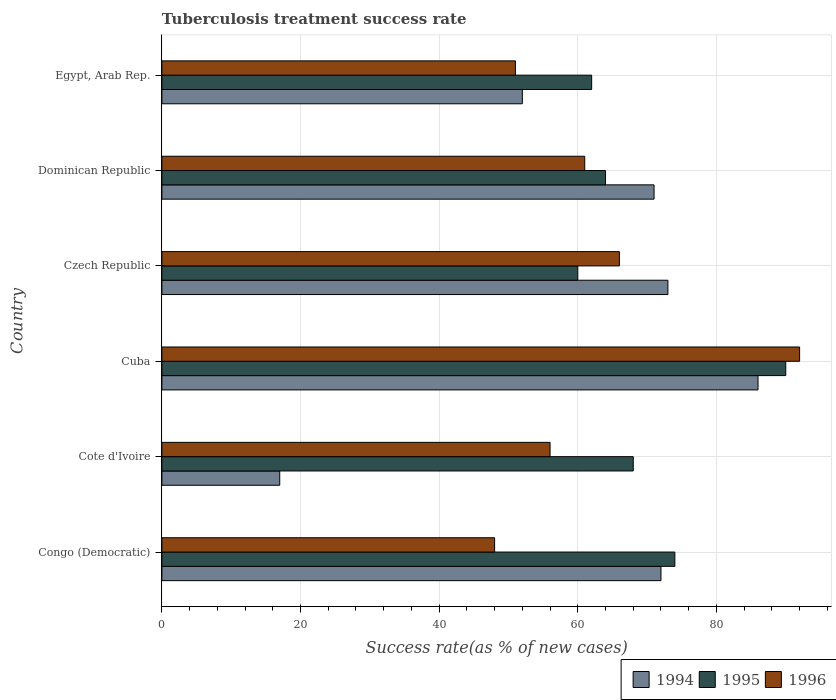Are the number of bars on each tick of the Y-axis equal?
Your response must be concise. Yes. How many bars are there on the 3rd tick from the bottom?
Keep it short and to the point. 3. What is the label of the 3rd group of bars from the top?
Offer a very short reply. Czech Republic. Across all countries, what is the maximum tuberculosis treatment success rate in 1994?
Give a very brief answer. 86. Across all countries, what is the minimum tuberculosis treatment success rate in 1995?
Give a very brief answer. 60. In which country was the tuberculosis treatment success rate in 1994 maximum?
Offer a very short reply. Cuba. In which country was the tuberculosis treatment success rate in 1995 minimum?
Your answer should be very brief. Czech Republic. What is the total tuberculosis treatment success rate in 1995 in the graph?
Your answer should be compact. 418. What is the difference between the tuberculosis treatment success rate in 1995 in Cote d'Ivoire and that in Egypt, Arab Rep.?
Make the answer very short. 6. What is the difference between the tuberculosis treatment success rate in 1996 in Czech Republic and the tuberculosis treatment success rate in 1994 in Dominican Republic?
Your answer should be compact. -5. What is the average tuberculosis treatment success rate in 1996 per country?
Your answer should be very brief. 62.33. What is the ratio of the tuberculosis treatment success rate in 1996 in Cote d'Ivoire to that in Egypt, Arab Rep.?
Your answer should be very brief. 1.1. What is the difference between the highest and the lowest tuberculosis treatment success rate in 1996?
Ensure brevity in your answer.  44. In how many countries, is the tuberculosis treatment success rate in 1994 greater than the average tuberculosis treatment success rate in 1994 taken over all countries?
Offer a very short reply. 4. Is the sum of the tuberculosis treatment success rate in 1994 in Cuba and Czech Republic greater than the maximum tuberculosis treatment success rate in 1995 across all countries?
Keep it short and to the point. Yes. What does the 3rd bar from the bottom in Dominican Republic represents?
Your answer should be compact. 1996. Is it the case that in every country, the sum of the tuberculosis treatment success rate in 1994 and tuberculosis treatment success rate in 1995 is greater than the tuberculosis treatment success rate in 1996?
Your answer should be compact. Yes. How many bars are there?
Your answer should be compact. 18. Are all the bars in the graph horizontal?
Provide a short and direct response. Yes. How many countries are there in the graph?
Your answer should be very brief. 6. What is the difference between two consecutive major ticks on the X-axis?
Offer a terse response. 20. Are the values on the major ticks of X-axis written in scientific E-notation?
Offer a very short reply. No. Does the graph contain grids?
Make the answer very short. Yes. Where does the legend appear in the graph?
Provide a succinct answer. Bottom right. How many legend labels are there?
Keep it short and to the point. 3. What is the title of the graph?
Offer a very short reply. Tuberculosis treatment success rate. Does "1980" appear as one of the legend labels in the graph?
Your answer should be compact. No. What is the label or title of the X-axis?
Make the answer very short. Success rate(as % of new cases). What is the Success rate(as % of new cases) in 1994 in Congo (Democratic)?
Ensure brevity in your answer.  72. What is the Success rate(as % of new cases) in 1995 in Congo (Democratic)?
Make the answer very short. 74. What is the Success rate(as % of new cases) in 1994 in Cote d'Ivoire?
Provide a succinct answer. 17. What is the Success rate(as % of new cases) of 1996 in Cote d'Ivoire?
Your answer should be compact. 56. What is the Success rate(as % of new cases) of 1996 in Cuba?
Give a very brief answer. 92. What is the Success rate(as % of new cases) in 1995 in Egypt, Arab Rep.?
Your answer should be compact. 62. Across all countries, what is the maximum Success rate(as % of new cases) of 1994?
Give a very brief answer. 86. Across all countries, what is the maximum Success rate(as % of new cases) of 1995?
Provide a succinct answer. 90. Across all countries, what is the maximum Success rate(as % of new cases) in 1996?
Ensure brevity in your answer.  92. Across all countries, what is the minimum Success rate(as % of new cases) of 1994?
Give a very brief answer. 17. Across all countries, what is the minimum Success rate(as % of new cases) of 1995?
Your answer should be compact. 60. Across all countries, what is the minimum Success rate(as % of new cases) of 1996?
Give a very brief answer. 48. What is the total Success rate(as % of new cases) in 1994 in the graph?
Make the answer very short. 371. What is the total Success rate(as % of new cases) in 1995 in the graph?
Ensure brevity in your answer.  418. What is the total Success rate(as % of new cases) of 1996 in the graph?
Provide a succinct answer. 374. What is the difference between the Success rate(as % of new cases) of 1996 in Congo (Democratic) and that in Cote d'Ivoire?
Give a very brief answer. -8. What is the difference between the Success rate(as % of new cases) of 1995 in Congo (Democratic) and that in Cuba?
Your response must be concise. -16. What is the difference between the Success rate(as % of new cases) of 1996 in Congo (Democratic) and that in Cuba?
Your response must be concise. -44. What is the difference between the Success rate(as % of new cases) of 1996 in Congo (Democratic) and that in Czech Republic?
Your answer should be very brief. -18. What is the difference between the Success rate(as % of new cases) of 1995 in Congo (Democratic) and that in Dominican Republic?
Your response must be concise. 10. What is the difference between the Success rate(as % of new cases) of 1994 in Congo (Democratic) and that in Egypt, Arab Rep.?
Your response must be concise. 20. What is the difference between the Success rate(as % of new cases) in 1996 in Congo (Democratic) and that in Egypt, Arab Rep.?
Ensure brevity in your answer.  -3. What is the difference between the Success rate(as % of new cases) in 1994 in Cote d'Ivoire and that in Cuba?
Your answer should be very brief. -69. What is the difference between the Success rate(as % of new cases) of 1995 in Cote d'Ivoire and that in Cuba?
Give a very brief answer. -22. What is the difference between the Success rate(as % of new cases) in 1996 in Cote d'Ivoire and that in Cuba?
Provide a short and direct response. -36. What is the difference between the Success rate(as % of new cases) in 1994 in Cote d'Ivoire and that in Czech Republic?
Provide a succinct answer. -56. What is the difference between the Success rate(as % of new cases) in 1994 in Cote d'Ivoire and that in Dominican Republic?
Your answer should be compact. -54. What is the difference between the Success rate(as % of new cases) of 1995 in Cote d'Ivoire and that in Dominican Republic?
Ensure brevity in your answer.  4. What is the difference between the Success rate(as % of new cases) of 1996 in Cote d'Ivoire and that in Dominican Republic?
Your answer should be very brief. -5. What is the difference between the Success rate(as % of new cases) of 1994 in Cote d'Ivoire and that in Egypt, Arab Rep.?
Provide a short and direct response. -35. What is the difference between the Success rate(as % of new cases) in 1996 in Cote d'Ivoire and that in Egypt, Arab Rep.?
Keep it short and to the point. 5. What is the difference between the Success rate(as % of new cases) of 1994 in Cuba and that in Czech Republic?
Provide a short and direct response. 13. What is the difference between the Success rate(as % of new cases) of 1996 in Cuba and that in Czech Republic?
Offer a terse response. 26. What is the difference between the Success rate(as % of new cases) of 1996 in Cuba and that in Dominican Republic?
Ensure brevity in your answer.  31. What is the difference between the Success rate(as % of new cases) of 1994 in Cuba and that in Egypt, Arab Rep.?
Your answer should be compact. 34. What is the difference between the Success rate(as % of new cases) of 1996 in Cuba and that in Egypt, Arab Rep.?
Give a very brief answer. 41. What is the difference between the Success rate(as % of new cases) of 1994 in Czech Republic and that in Dominican Republic?
Make the answer very short. 2. What is the difference between the Success rate(as % of new cases) of 1995 in Czech Republic and that in Dominican Republic?
Provide a succinct answer. -4. What is the difference between the Success rate(as % of new cases) in 1996 in Czech Republic and that in Egypt, Arab Rep.?
Your answer should be compact. 15. What is the difference between the Success rate(as % of new cases) in 1994 in Dominican Republic and that in Egypt, Arab Rep.?
Make the answer very short. 19. What is the difference between the Success rate(as % of new cases) of 1995 in Dominican Republic and that in Egypt, Arab Rep.?
Offer a terse response. 2. What is the difference between the Success rate(as % of new cases) of 1996 in Dominican Republic and that in Egypt, Arab Rep.?
Provide a succinct answer. 10. What is the difference between the Success rate(as % of new cases) of 1995 in Congo (Democratic) and the Success rate(as % of new cases) of 1996 in Cote d'Ivoire?
Offer a very short reply. 18. What is the difference between the Success rate(as % of new cases) of 1994 in Congo (Democratic) and the Success rate(as % of new cases) of 1995 in Cuba?
Keep it short and to the point. -18. What is the difference between the Success rate(as % of new cases) of 1995 in Congo (Democratic) and the Success rate(as % of new cases) of 1996 in Cuba?
Your response must be concise. -18. What is the difference between the Success rate(as % of new cases) in 1994 in Congo (Democratic) and the Success rate(as % of new cases) in 1995 in Czech Republic?
Offer a very short reply. 12. What is the difference between the Success rate(as % of new cases) of 1994 in Congo (Democratic) and the Success rate(as % of new cases) of 1996 in Czech Republic?
Give a very brief answer. 6. What is the difference between the Success rate(as % of new cases) in 1995 in Congo (Democratic) and the Success rate(as % of new cases) in 1996 in Egypt, Arab Rep.?
Ensure brevity in your answer.  23. What is the difference between the Success rate(as % of new cases) of 1994 in Cote d'Ivoire and the Success rate(as % of new cases) of 1995 in Cuba?
Your answer should be very brief. -73. What is the difference between the Success rate(as % of new cases) in 1994 in Cote d'Ivoire and the Success rate(as % of new cases) in 1996 in Cuba?
Ensure brevity in your answer.  -75. What is the difference between the Success rate(as % of new cases) of 1995 in Cote d'Ivoire and the Success rate(as % of new cases) of 1996 in Cuba?
Keep it short and to the point. -24. What is the difference between the Success rate(as % of new cases) of 1994 in Cote d'Ivoire and the Success rate(as % of new cases) of 1995 in Czech Republic?
Ensure brevity in your answer.  -43. What is the difference between the Success rate(as % of new cases) in 1994 in Cote d'Ivoire and the Success rate(as % of new cases) in 1996 in Czech Republic?
Provide a short and direct response. -49. What is the difference between the Success rate(as % of new cases) of 1994 in Cote d'Ivoire and the Success rate(as % of new cases) of 1995 in Dominican Republic?
Offer a very short reply. -47. What is the difference between the Success rate(as % of new cases) of 1994 in Cote d'Ivoire and the Success rate(as % of new cases) of 1996 in Dominican Republic?
Your response must be concise. -44. What is the difference between the Success rate(as % of new cases) in 1994 in Cote d'Ivoire and the Success rate(as % of new cases) in 1995 in Egypt, Arab Rep.?
Your response must be concise. -45. What is the difference between the Success rate(as % of new cases) in 1994 in Cote d'Ivoire and the Success rate(as % of new cases) in 1996 in Egypt, Arab Rep.?
Your answer should be compact. -34. What is the difference between the Success rate(as % of new cases) in 1995 in Cote d'Ivoire and the Success rate(as % of new cases) in 1996 in Egypt, Arab Rep.?
Your answer should be very brief. 17. What is the difference between the Success rate(as % of new cases) of 1994 in Cuba and the Success rate(as % of new cases) of 1995 in Dominican Republic?
Provide a short and direct response. 22. What is the difference between the Success rate(as % of new cases) in 1995 in Cuba and the Success rate(as % of new cases) in 1996 in Dominican Republic?
Provide a short and direct response. 29. What is the difference between the Success rate(as % of new cases) in 1995 in Cuba and the Success rate(as % of new cases) in 1996 in Egypt, Arab Rep.?
Give a very brief answer. 39. What is the difference between the Success rate(as % of new cases) of 1994 in Czech Republic and the Success rate(as % of new cases) of 1995 in Dominican Republic?
Provide a succinct answer. 9. What is the difference between the Success rate(as % of new cases) in 1994 in Czech Republic and the Success rate(as % of new cases) in 1996 in Dominican Republic?
Your response must be concise. 12. What is the difference between the Success rate(as % of new cases) of 1994 in Czech Republic and the Success rate(as % of new cases) of 1995 in Egypt, Arab Rep.?
Your answer should be very brief. 11. What is the difference between the Success rate(as % of new cases) of 1995 in Czech Republic and the Success rate(as % of new cases) of 1996 in Egypt, Arab Rep.?
Provide a short and direct response. 9. What is the difference between the Success rate(as % of new cases) in 1994 in Dominican Republic and the Success rate(as % of new cases) in 1996 in Egypt, Arab Rep.?
Your answer should be very brief. 20. What is the average Success rate(as % of new cases) of 1994 per country?
Offer a terse response. 61.83. What is the average Success rate(as % of new cases) of 1995 per country?
Give a very brief answer. 69.67. What is the average Success rate(as % of new cases) in 1996 per country?
Keep it short and to the point. 62.33. What is the difference between the Success rate(as % of new cases) of 1994 and Success rate(as % of new cases) of 1996 in Congo (Democratic)?
Offer a terse response. 24. What is the difference between the Success rate(as % of new cases) in 1995 and Success rate(as % of new cases) in 1996 in Congo (Democratic)?
Give a very brief answer. 26. What is the difference between the Success rate(as % of new cases) in 1994 and Success rate(as % of new cases) in 1995 in Cote d'Ivoire?
Provide a succinct answer. -51. What is the difference between the Success rate(as % of new cases) of 1994 and Success rate(as % of new cases) of 1996 in Cote d'Ivoire?
Keep it short and to the point. -39. What is the difference between the Success rate(as % of new cases) of 1994 and Success rate(as % of new cases) of 1996 in Cuba?
Keep it short and to the point. -6. What is the difference between the Success rate(as % of new cases) in 1994 and Success rate(as % of new cases) in 1995 in Czech Republic?
Ensure brevity in your answer.  13. What is the difference between the Success rate(as % of new cases) in 1995 and Success rate(as % of new cases) in 1996 in Czech Republic?
Ensure brevity in your answer.  -6. What is the difference between the Success rate(as % of new cases) of 1994 and Success rate(as % of new cases) of 1996 in Egypt, Arab Rep.?
Offer a very short reply. 1. What is the difference between the Success rate(as % of new cases) of 1995 and Success rate(as % of new cases) of 1996 in Egypt, Arab Rep.?
Provide a short and direct response. 11. What is the ratio of the Success rate(as % of new cases) in 1994 in Congo (Democratic) to that in Cote d'Ivoire?
Provide a succinct answer. 4.24. What is the ratio of the Success rate(as % of new cases) in 1995 in Congo (Democratic) to that in Cote d'Ivoire?
Offer a terse response. 1.09. What is the ratio of the Success rate(as % of new cases) in 1994 in Congo (Democratic) to that in Cuba?
Offer a terse response. 0.84. What is the ratio of the Success rate(as % of new cases) of 1995 in Congo (Democratic) to that in Cuba?
Offer a very short reply. 0.82. What is the ratio of the Success rate(as % of new cases) in 1996 in Congo (Democratic) to that in Cuba?
Provide a short and direct response. 0.52. What is the ratio of the Success rate(as % of new cases) in 1994 in Congo (Democratic) to that in Czech Republic?
Your answer should be very brief. 0.99. What is the ratio of the Success rate(as % of new cases) of 1995 in Congo (Democratic) to that in Czech Republic?
Your response must be concise. 1.23. What is the ratio of the Success rate(as % of new cases) in 1996 in Congo (Democratic) to that in Czech Republic?
Offer a terse response. 0.73. What is the ratio of the Success rate(as % of new cases) in 1994 in Congo (Democratic) to that in Dominican Republic?
Keep it short and to the point. 1.01. What is the ratio of the Success rate(as % of new cases) of 1995 in Congo (Democratic) to that in Dominican Republic?
Your answer should be compact. 1.16. What is the ratio of the Success rate(as % of new cases) in 1996 in Congo (Democratic) to that in Dominican Republic?
Provide a succinct answer. 0.79. What is the ratio of the Success rate(as % of new cases) in 1994 in Congo (Democratic) to that in Egypt, Arab Rep.?
Provide a short and direct response. 1.38. What is the ratio of the Success rate(as % of new cases) of 1995 in Congo (Democratic) to that in Egypt, Arab Rep.?
Ensure brevity in your answer.  1.19. What is the ratio of the Success rate(as % of new cases) of 1994 in Cote d'Ivoire to that in Cuba?
Make the answer very short. 0.2. What is the ratio of the Success rate(as % of new cases) of 1995 in Cote d'Ivoire to that in Cuba?
Ensure brevity in your answer.  0.76. What is the ratio of the Success rate(as % of new cases) in 1996 in Cote d'Ivoire to that in Cuba?
Give a very brief answer. 0.61. What is the ratio of the Success rate(as % of new cases) of 1994 in Cote d'Ivoire to that in Czech Republic?
Offer a terse response. 0.23. What is the ratio of the Success rate(as % of new cases) in 1995 in Cote d'Ivoire to that in Czech Republic?
Ensure brevity in your answer.  1.13. What is the ratio of the Success rate(as % of new cases) in 1996 in Cote d'Ivoire to that in Czech Republic?
Offer a very short reply. 0.85. What is the ratio of the Success rate(as % of new cases) in 1994 in Cote d'Ivoire to that in Dominican Republic?
Your answer should be compact. 0.24. What is the ratio of the Success rate(as % of new cases) in 1995 in Cote d'Ivoire to that in Dominican Republic?
Your response must be concise. 1.06. What is the ratio of the Success rate(as % of new cases) of 1996 in Cote d'Ivoire to that in Dominican Republic?
Offer a terse response. 0.92. What is the ratio of the Success rate(as % of new cases) of 1994 in Cote d'Ivoire to that in Egypt, Arab Rep.?
Keep it short and to the point. 0.33. What is the ratio of the Success rate(as % of new cases) in 1995 in Cote d'Ivoire to that in Egypt, Arab Rep.?
Your answer should be very brief. 1.1. What is the ratio of the Success rate(as % of new cases) in 1996 in Cote d'Ivoire to that in Egypt, Arab Rep.?
Provide a succinct answer. 1.1. What is the ratio of the Success rate(as % of new cases) of 1994 in Cuba to that in Czech Republic?
Your response must be concise. 1.18. What is the ratio of the Success rate(as % of new cases) in 1995 in Cuba to that in Czech Republic?
Keep it short and to the point. 1.5. What is the ratio of the Success rate(as % of new cases) of 1996 in Cuba to that in Czech Republic?
Your answer should be compact. 1.39. What is the ratio of the Success rate(as % of new cases) in 1994 in Cuba to that in Dominican Republic?
Make the answer very short. 1.21. What is the ratio of the Success rate(as % of new cases) of 1995 in Cuba to that in Dominican Republic?
Your response must be concise. 1.41. What is the ratio of the Success rate(as % of new cases) in 1996 in Cuba to that in Dominican Republic?
Make the answer very short. 1.51. What is the ratio of the Success rate(as % of new cases) of 1994 in Cuba to that in Egypt, Arab Rep.?
Your response must be concise. 1.65. What is the ratio of the Success rate(as % of new cases) in 1995 in Cuba to that in Egypt, Arab Rep.?
Make the answer very short. 1.45. What is the ratio of the Success rate(as % of new cases) in 1996 in Cuba to that in Egypt, Arab Rep.?
Keep it short and to the point. 1.8. What is the ratio of the Success rate(as % of new cases) in 1994 in Czech Republic to that in Dominican Republic?
Keep it short and to the point. 1.03. What is the ratio of the Success rate(as % of new cases) of 1996 in Czech Republic to that in Dominican Republic?
Give a very brief answer. 1.08. What is the ratio of the Success rate(as % of new cases) of 1994 in Czech Republic to that in Egypt, Arab Rep.?
Offer a terse response. 1.4. What is the ratio of the Success rate(as % of new cases) in 1995 in Czech Republic to that in Egypt, Arab Rep.?
Your response must be concise. 0.97. What is the ratio of the Success rate(as % of new cases) in 1996 in Czech Republic to that in Egypt, Arab Rep.?
Offer a terse response. 1.29. What is the ratio of the Success rate(as % of new cases) in 1994 in Dominican Republic to that in Egypt, Arab Rep.?
Provide a short and direct response. 1.37. What is the ratio of the Success rate(as % of new cases) of 1995 in Dominican Republic to that in Egypt, Arab Rep.?
Provide a succinct answer. 1.03. What is the ratio of the Success rate(as % of new cases) in 1996 in Dominican Republic to that in Egypt, Arab Rep.?
Provide a short and direct response. 1.2. What is the difference between the highest and the second highest Success rate(as % of new cases) of 1996?
Your response must be concise. 26. What is the difference between the highest and the lowest Success rate(as % of new cases) of 1994?
Provide a succinct answer. 69. 